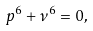Convert formula to latex. <formula><loc_0><loc_0><loc_500><loc_500>p ^ { 6 } + \nu ^ { 6 } = 0 ,</formula> 